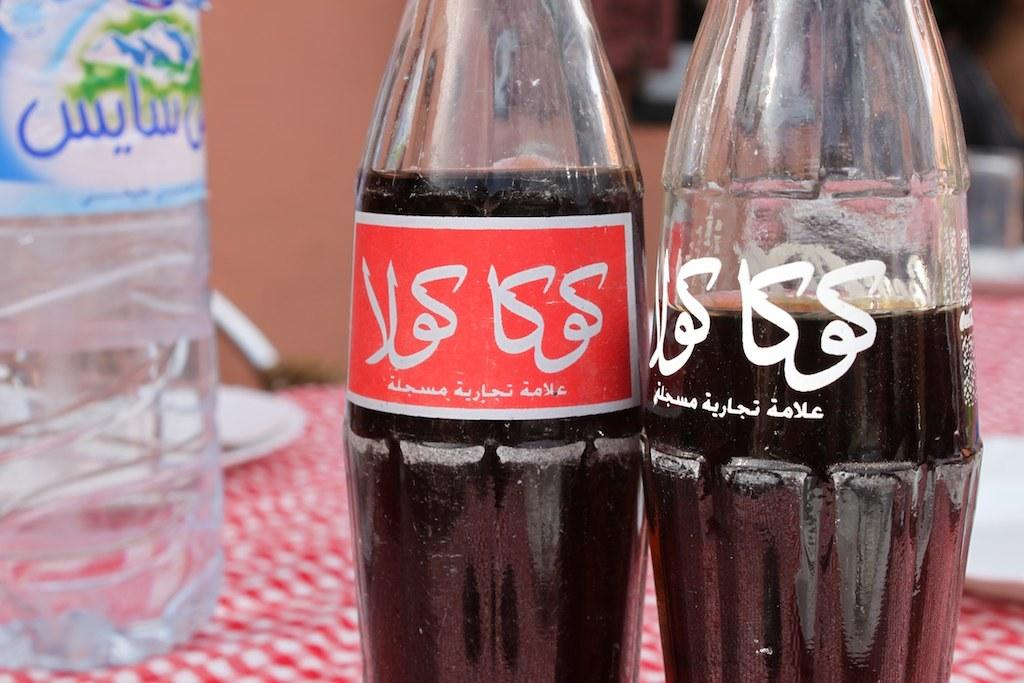What objects are on the table in the image? There are bottles on the table in the image. How many bottles are on the table? The number of bottles on the table cannot be determined from the provided fact. What might be the purpose of the bottles on the table? The purpose of the bottles on the table cannot be determined from the provided fact. How many pages are in the book that is being drained on the table? There is no book or draining activity present in the image; it only features bottles on a table. 